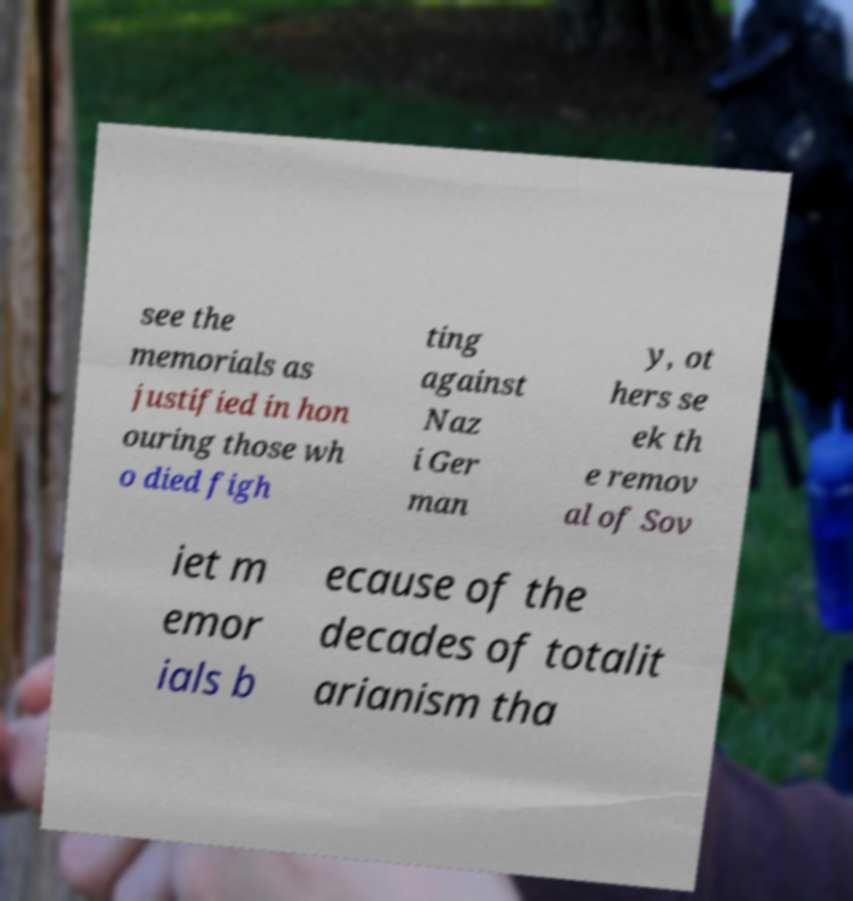Can you read and provide the text displayed in the image?This photo seems to have some interesting text. Can you extract and type it out for me? see the memorials as justified in hon ouring those wh o died figh ting against Naz i Ger man y, ot hers se ek th e remov al of Sov iet m emor ials b ecause of the decades of totalit arianism tha 